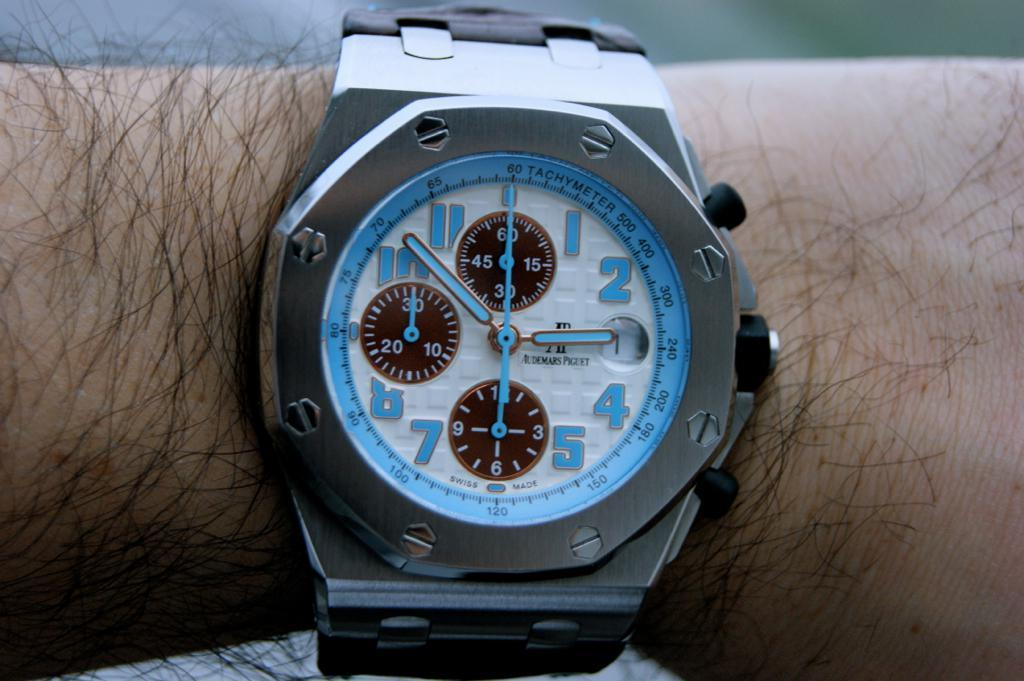<image>
Summarize the visual content of the image. the number 2 is on the wrist of a person 